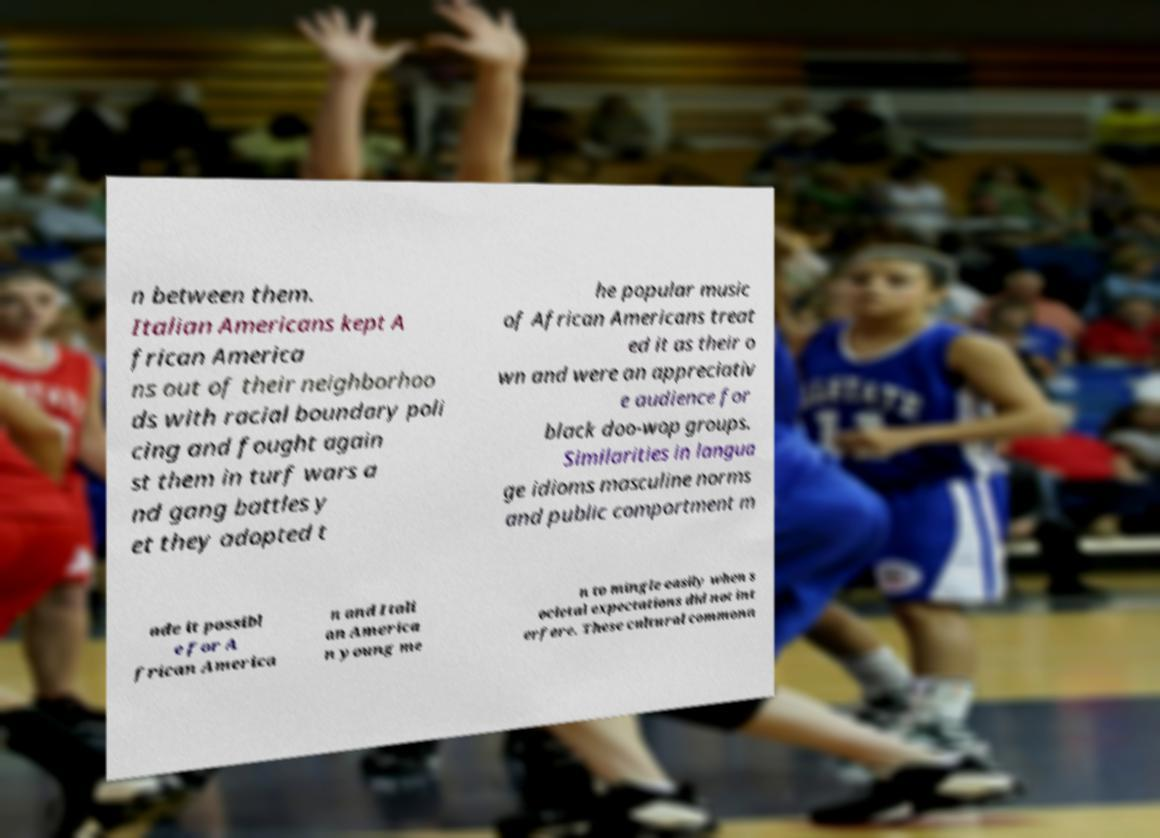What messages or text are displayed in this image? I need them in a readable, typed format. n between them. Italian Americans kept A frican America ns out of their neighborhoo ds with racial boundary poli cing and fought again st them in turf wars a nd gang battles y et they adopted t he popular music of African Americans treat ed it as their o wn and were an appreciativ e audience for black doo-wop groups. Similarities in langua ge idioms masculine norms and public comportment m ade it possibl e for A frican America n and Itali an America n young me n to mingle easily when s ocietal expectations did not int erfere. These cultural commona 